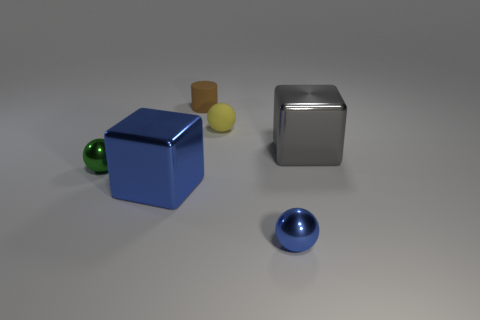Are any gray objects visible?
Your answer should be very brief. Yes. There is a metallic cube on the right side of the cube that is in front of the big thing to the right of the yellow matte thing; what size is it?
Keep it short and to the point. Large. How many other things are the same size as the brown rubber cylinder?
Offer a terse response. 3. There is a cube that is on the left side of the brown matte cylinder; what is its size?
Offer a very short reply. Large. Is there anything else of the same color as the small matte cylinder?
Your response must be concise. No. Is the material of the cube that is right of the brown object the same as the green object?
Provide a succinct answer. Yes. What number of tiny objects are both on the right side of the small yellow object and behind the yellow rubber thing?
Offer a terse response. 0. There is a gray metal cube that is in front of the brown cylinder to the left of the blue metal ball; what size is it?
Your response must be concise. Large. Are there any other things that have the same material as the small brown object?
Provide a succinct answer. Yes. Is the number of tiny blue objects greater than the number of large cyan shiny cubes?
Your response must be concise. Yes. 